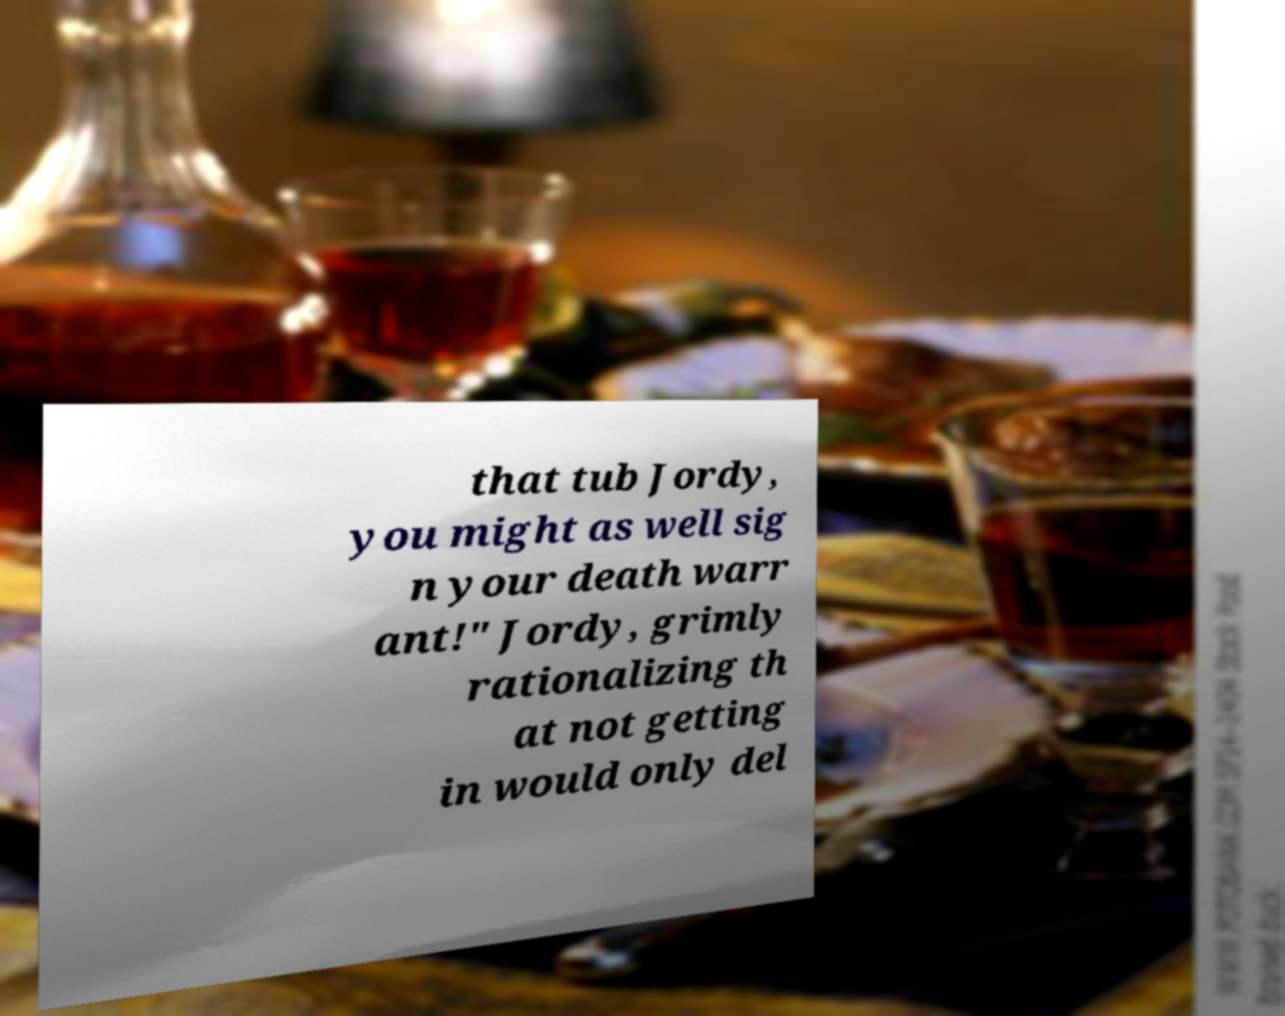Can you read and provide the text displayed in the image?This photo seems to have some interesting text. Can you extract and type it out for me? that tub Jordy, you might as well sig n your death warr ant!" Jordy, grimly rationalizing th at not getting in would only del 